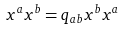Convert formula to latex. <formula><loc_0><loc_0><loc_500><loc_500>x ^ { a } x ^ { b } = q _ { a b } x ^ { b } x ^ { a }</formula> 